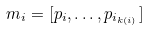Convert formula to latex. <formula><loc_0><loc_0><loc_500><loc_500>m _ { i } = [ p _ { i } , \dots , p _ { i _ { k ( i ) } } ]</formula> 